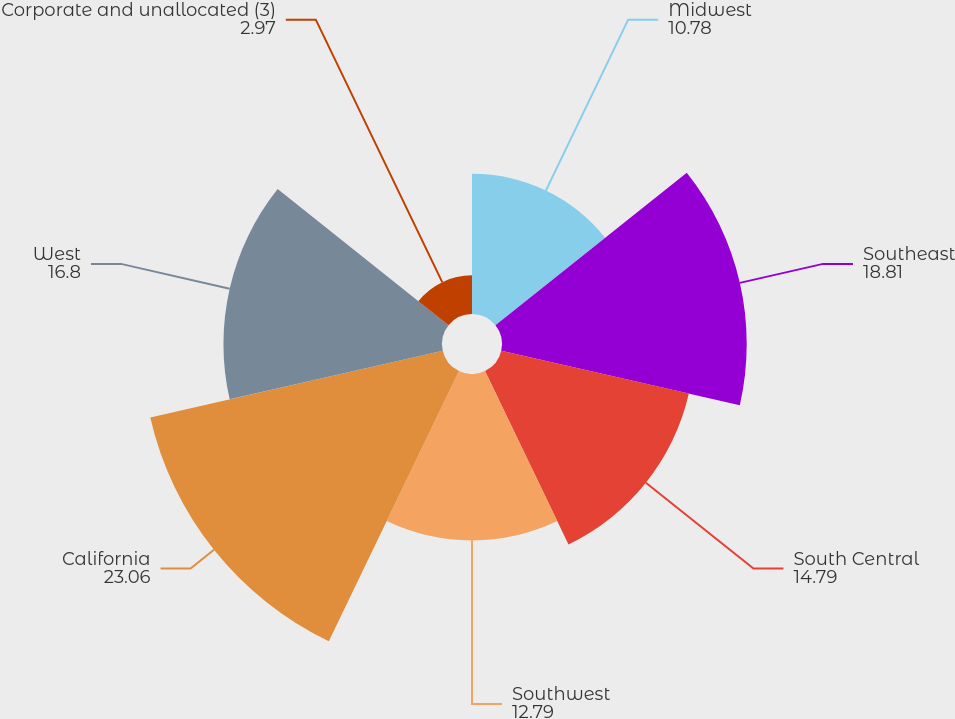<chart> <loc_0><loc_0><loc_500><loc_500><pie_chart><fcel>Midwest<fcel>Southeast<fcel>South Central<fcel>Southwest<fcel>California<fcel>West<fcel>Corporate and unallocated (3)<nl><fcel>10.78%<fcel>18.81%<fcel>14.79%<fcel>12.79%<fcel>23.06%<fcel>16.8%<fcel>2.97%<nl></chart> 